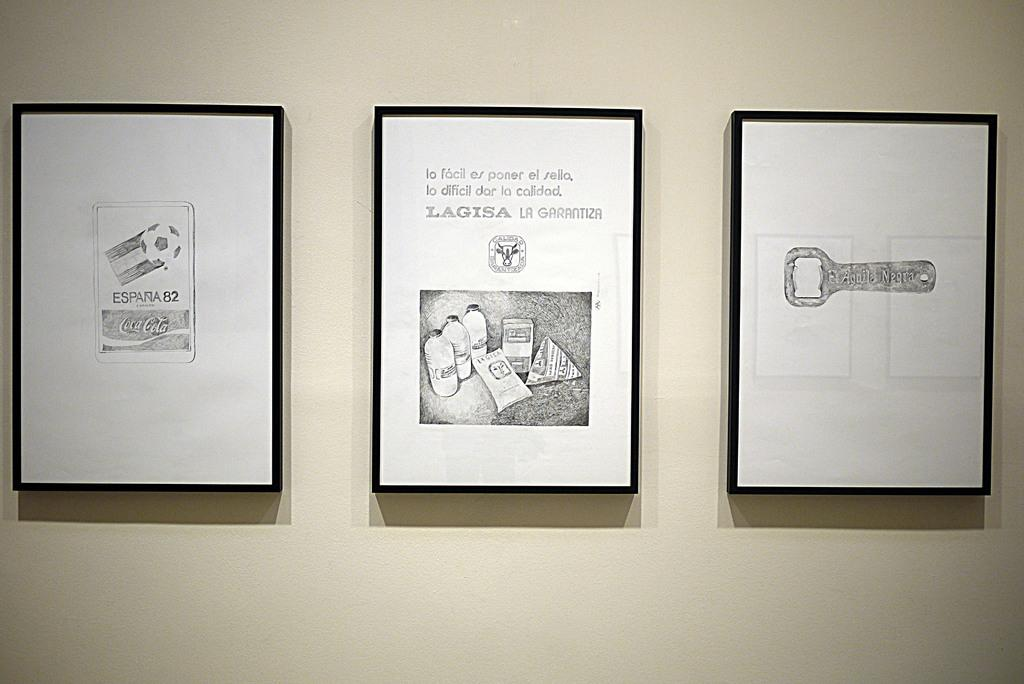<image>
Present a compact description of the photo's key features. Three black and white images are framed on a wall, the far left with a Coca-Cola logo on it. 